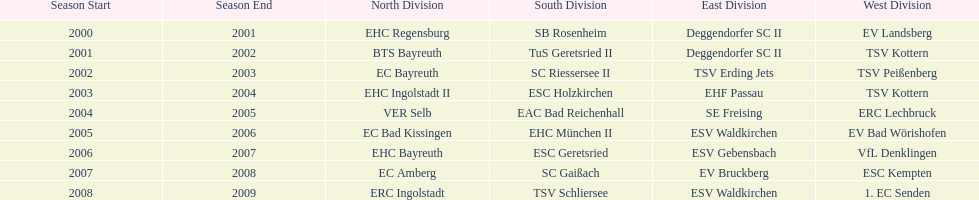Who won the season in the north before ec bayreuth did in 2002-03? BTS Bayreuth. 